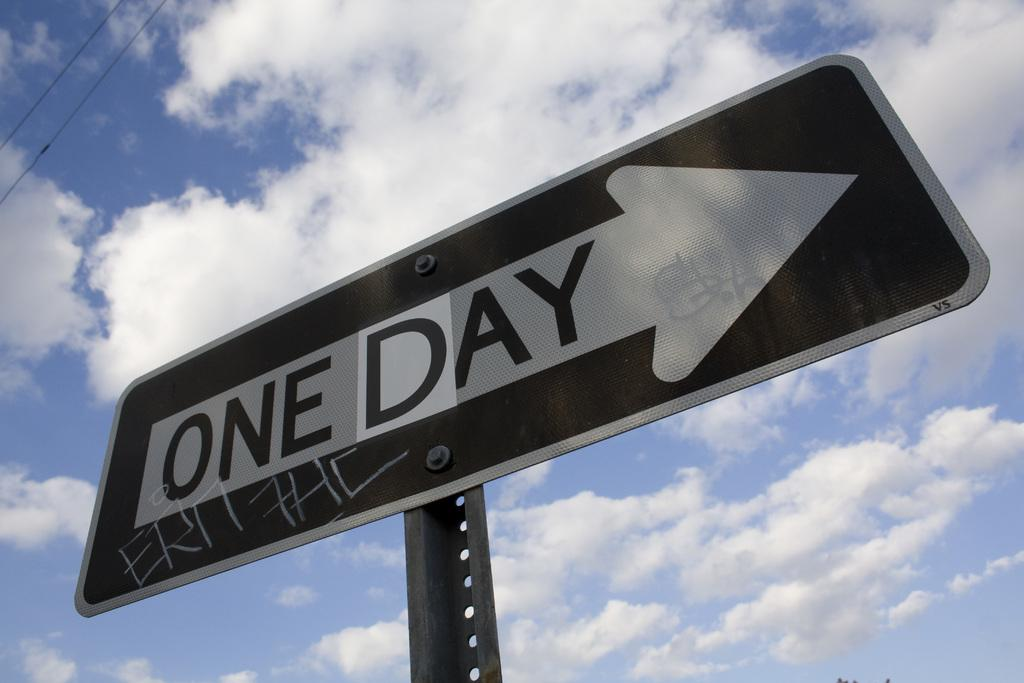<image>
Describe the image concisely. A one way sign has had the w replaced with a d so it says one day. 